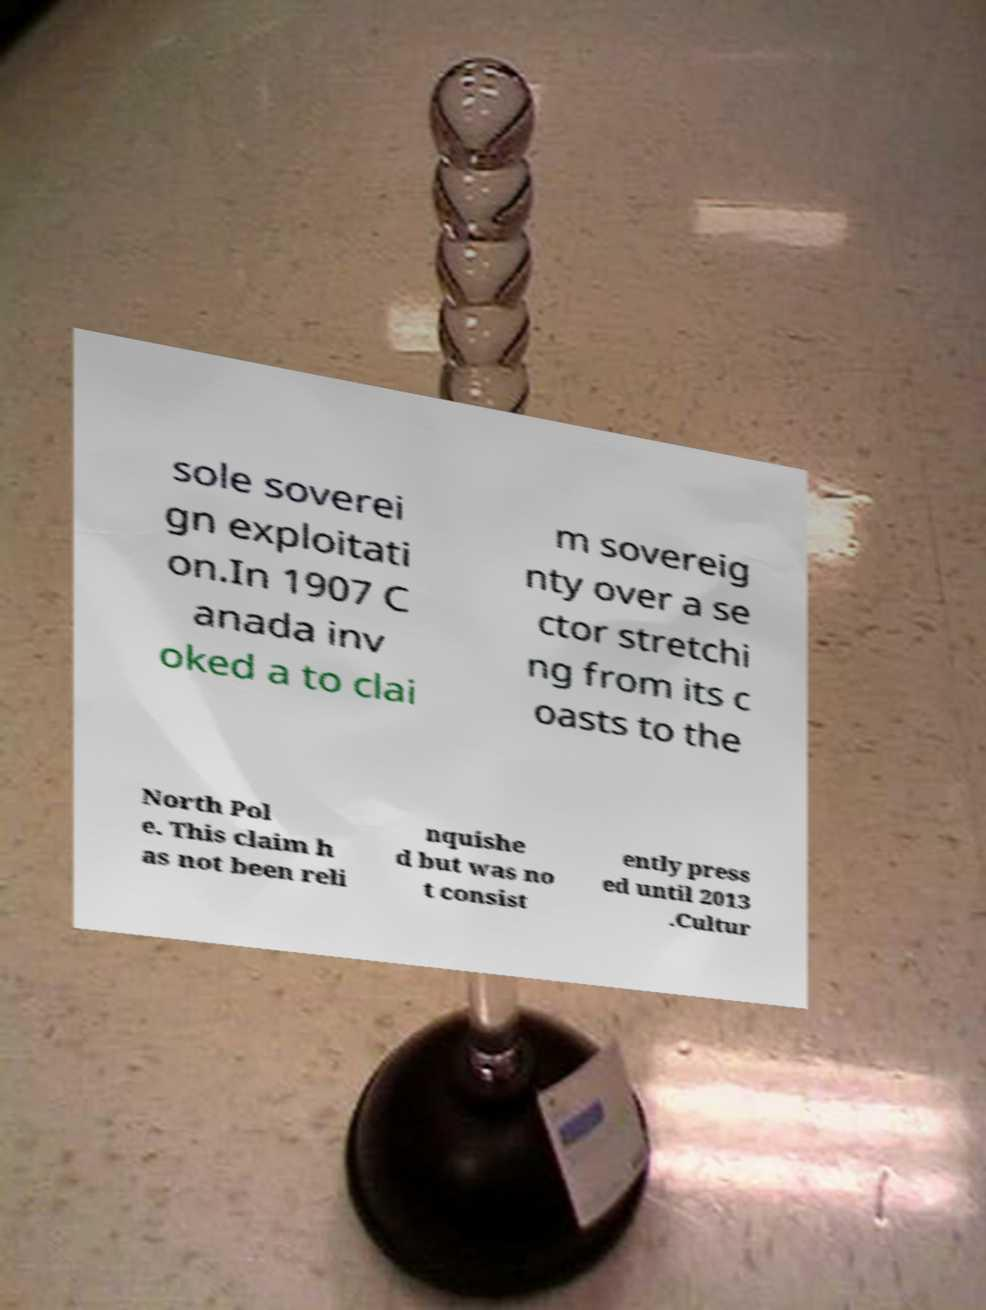Can you read and provide the text displayed in the image?This photo seems to have some interesting text. Can you extract and type it out for me? sole soverei gn exploitati on.In 1907 C anada inv oked a to clai m sovereig nty over a se ctor stretchi ng from its c oasts to the North Pol e. This claim h as not been reli nquishe d but was no t consist ently press ed until 2013 .Cultur 